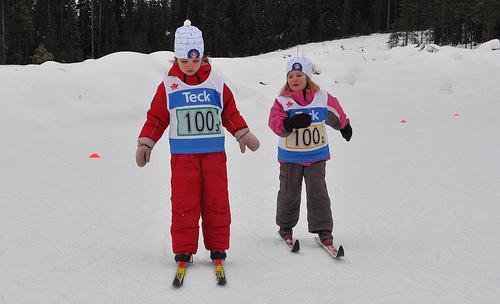How many people are there?
Give a very brief answer. 2. 